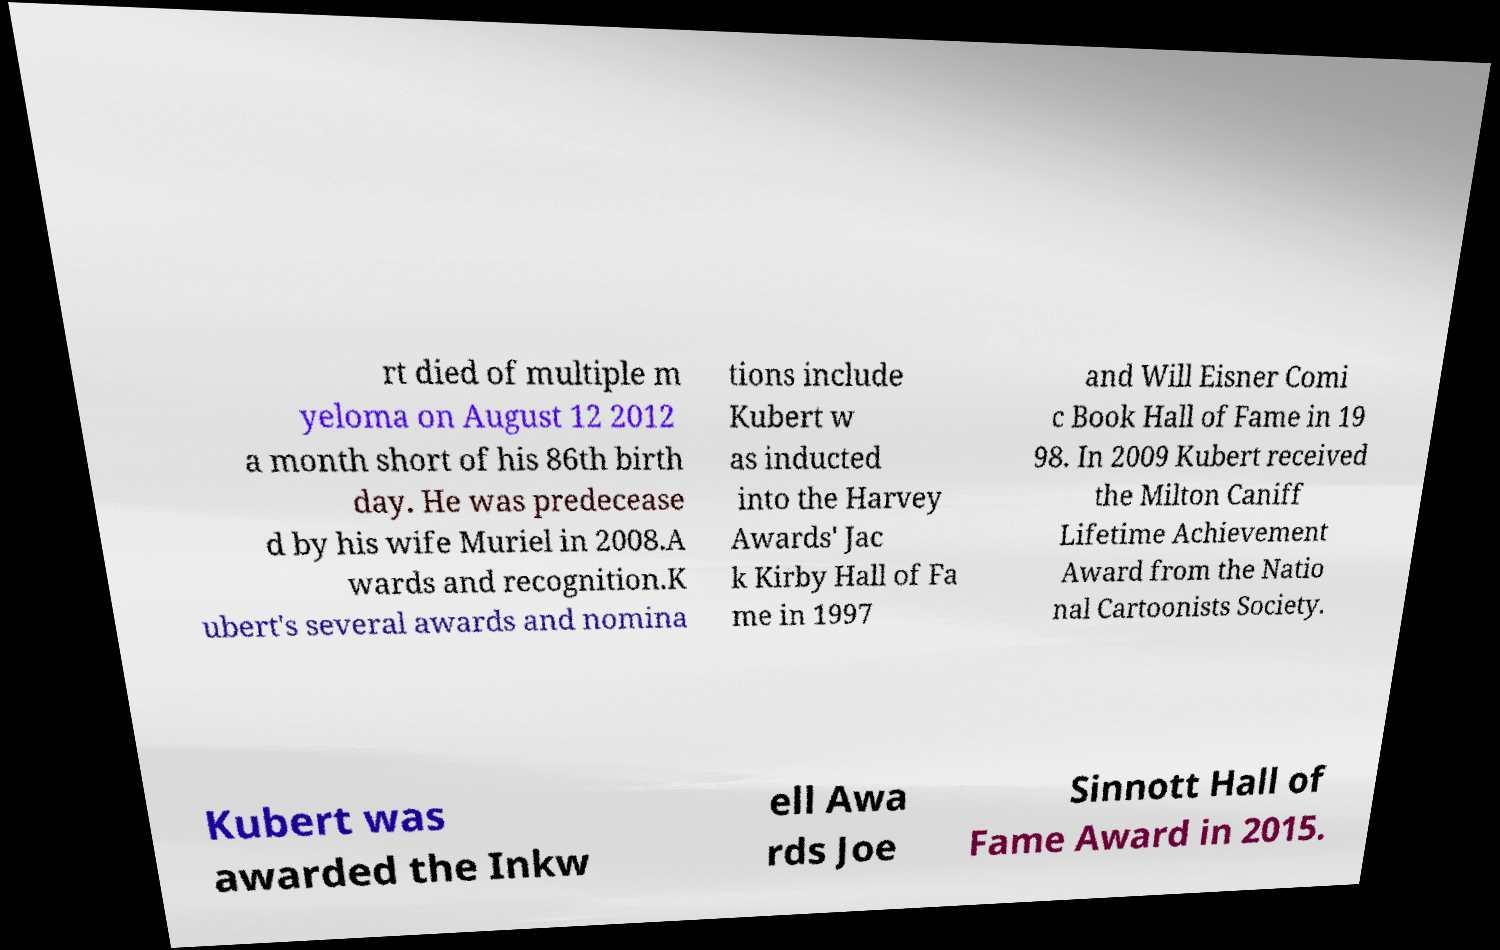What messages or text are displayed in this image? I need them in a readable, typed format. rt died of multiple m yeloma on August 12 2012 a month short of his 86th birth day. He was predecease d by his wife Muriel in 2008.A wards and recognition.K ubert's several awards and nomina tions include Kubert w as inducted into the Harvey Awards' Jac k Kirby Hall of Fa me in 1997 and Will Eisner Comi c Book Hall of Fame in 19 98. In 2009 Kubert received the Milton Caniff Lifetime Achievement Award from the Natio nal Cartoonists Society. Kubert was awarded the Inkw ell Awa rds Joe Sinnott Hall of Fame Award in 2015. 